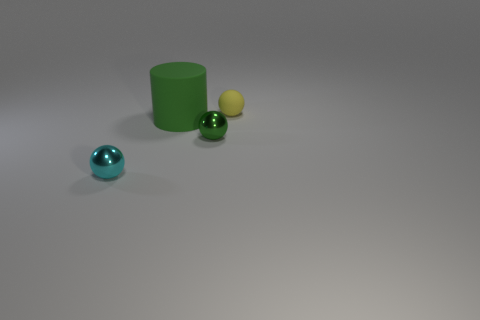Add 1 yellow metallic cylinders. How many objects exist? 5 Subtract all metal balls. How many balls are left? 1 Subtract all spheres. How many objects are left? 1 Subtract all tiny green shiny spheres. Subtract all metallic balls. How many objects are left? 1 Add 4 small shiny things. How many small shiny things are left? 6 Add 3 small green things. How many small green things exist? 4 Subtract 0 red cylinders. How many objects are left? 4 